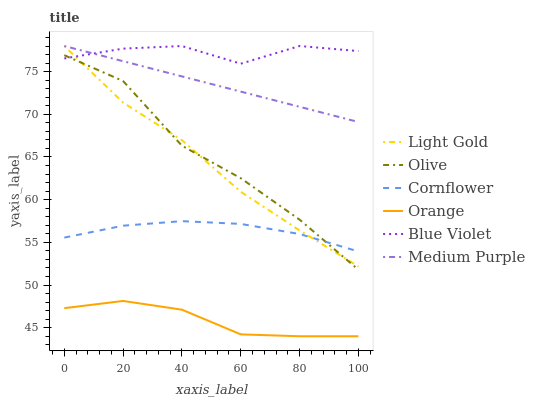Does Orange have the minimum area under the curve?
Answer yes or no. Yes. Does Blue Violet have the maximum area under the curve?
Answer yes or no. Yes. Does Medium Purple have the minimum area under the curve?
Answer yes or no. No. Does Medium Purple have the maximum area under the curve?
Answer yes or no. No. Is Medium Purple the smoothest?
Answer yes or no. Yes. Is Olive the roughest?
Answer yes or no. Yes. Is Orange the smoothest?
Answer yes or no. No. Is Orange the roughest?
Answer yes or no. No. Does Medium Purple have the lowest value?
Answer yes or no. No. Does Blue Violet have the highest value?
Answer yes or no. Yes. Does Orange have the highest value?
Answer yes or no. No. Is Cornflower less than Medium Purple?
Answer yes or no. Yes. Is Medium Purple greater than Orange?
Answer yes or no. Yes. Does Light Gold intersect Medium Purple?
Answer yes or no. Yes. Is Light Gold less than Medium Purple?
Answer yes or no. No. Is Light Gold greater than Medium Purple?
Answer yes or no. No. Does Cornflower intersect Medium Purple?
Answer yes or no. No. 